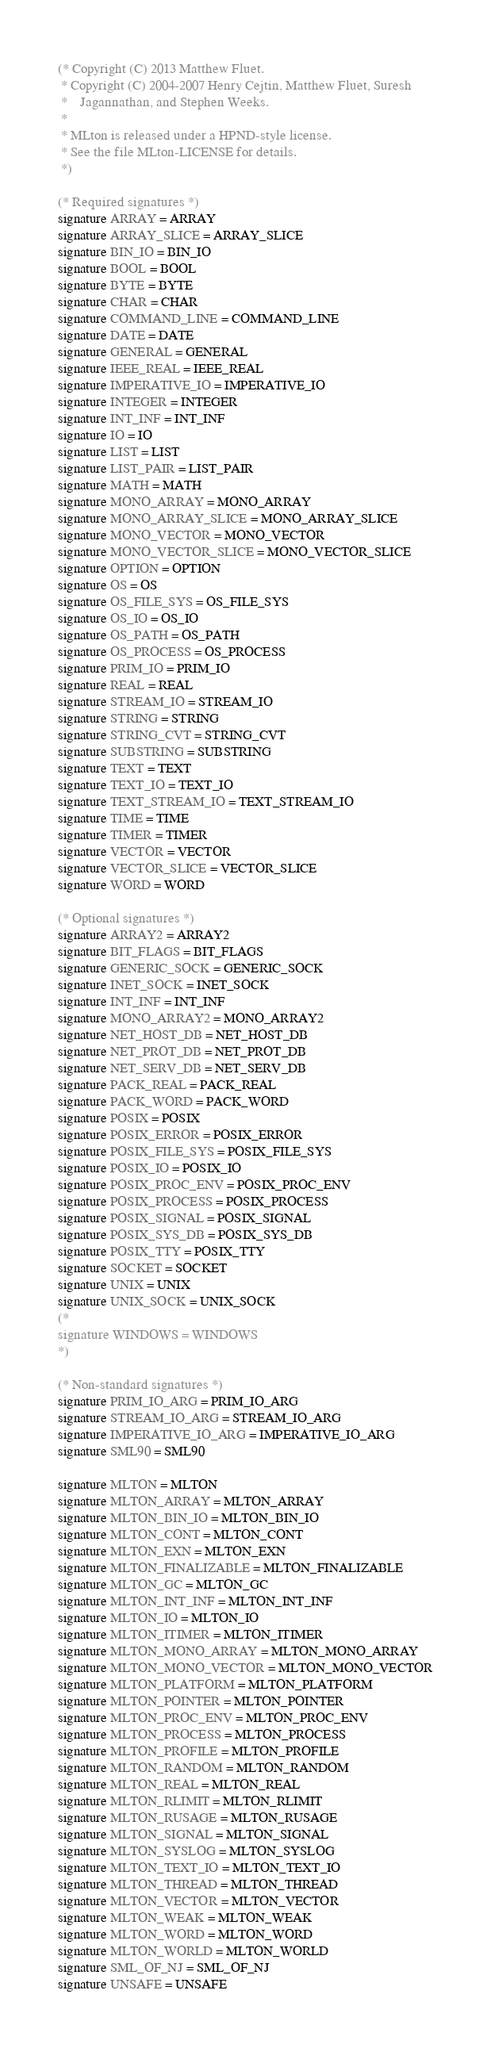<code> <loc_0><loc_0><loc_500><loc_500><_SML_>(* Copyright (C) 2013 Matthew Fluet.
 * Copyright (C) 2004-2007 Henry Cejtin, Matthew Fluet, Suresh
 *    Jagannathan, and Stephen Weeks.
 *
 * MLton is released under a HPND-style license.
 * See the file MLton-LICENSE for details.
 *)

(* Required signatures *)
signature ARRAY = ARRAY 
signature ARRAY_SLICE = ARRAY_SLICE 
signature BIN_IO = BIN_IO 
signature BOOL = BOOL 
signature BYTE = BYTE 
signature CHAR = CHAR 
signature COMMAND_LINE = COMMAND_LINE 
signature DATE = DATE 
signature GENERAL = GENERAL 
signature IEEE_REAL = IEEE_REAL 
signature IMPERATIVE_IO = IMPERATIVE_IO 
signature INTEGER = INTEGER 
signature INT_INF = INT_INF 
signature IO = IO 
signature LIST = LIST 
signature LIST_PAIR = LIST_PAIR 
signature MATH = MATH 
signature MONO_ARRAY = MONO_ARRAY 
signature MONO_ARRAY_SLICE = MONO_ARRAY_SLICE 
signature MONO_VECTOR = MONO_VECTOR 
signature MONO_VECTOR_SLICE = MONO_VECTOR_SLICE 
signature OPTION = OPTION 
signature OS = OS 
signature OS_FILE_SYS = OS_FILE_SYS 
signature OS_IO = OS_IO 
signature OS_PATH = OS_PATH 
signature OS_PROCESS = OS_PROCESS 
signature PRIM_IO = PRIM_IO 
signature REAL = REAL 
signature STREAM_IO = STREAM_IO
signature STRING = STRING 
signature STRING_CVT = STRING_CVT 
signature SUBSTRING = SUBSTRING 
signature TEXT = TEXT 
signature TEXT_IO = TEXT_IO 
signature TEXT_STREAM_IO = TEXT_STREAM_IO 
signature TIME = TIME 
signature TIMER = TIMER 
signature VECTOR = VECTOR 
signature VECTOR_SLICE = VECTOR_SLICE 
signature WORD = WORD

(* Optional signatures *)
signature ARRAY2 = ARRAY2 
signature BIT_FLAGS = BIT_FLAGS 
signature GENERIC_SOCK = GENERIC_SOCK 
signature INET_SOCK = INET_SOCK 
signature INT_INF = INT_INF 
signature MONO_ARRAY2 = MONO_ARRAY2 
signature NET_HOST_DB = NET_HOST_DB 
signature NET_PROT_DB = NET_PROT_DB 
signature NET_SERV_DB = NET_SERV_DB 
signature PACK_REAL = PACK_REAL 
signature PACK_WORD = PACK_WORD 
signature POSIX = POSIX 
signature POSIX_ERROR = POSIX_ERROR 
signature POSIX_FILE_SYS = POSIX_FILE_SYS 
signature POSIX_IO = POSIX_IO 
signature POSIX_PROC_ENV = POSIX_PROC_ENV 
signature POSIX_PROCESS = POSIX_PROCESS 
signature POSIX_SIGNAL = POSIX_SIGNAL 
signature POSIX_SYS_DB = POSIX_SYS_DB 
signature POSIX_TTY = POSIX_TTY 
signature SOCKET = SOCKET 
signature UNIX = UNIX 
signature UNIX_SOCK = UNIX_SOCK 
(*
signature WINDOWS = WINDOWS
*)

(* Non-standard signatures *)
signature PRIM_IO_ARG = PRIM_IO_ARG
signature STREAM_IO_ARG = STREAM_IO_ARG
signature IMPERATIVE_IO_ARG = IMPERATIVE_IO_ARG
signature SML90 = SML90

signature MLTON = MLTON
signature MLTON_ARRAY = MLTON_ARRAY
signature MLTON_BIN_IO = MLTON_BIN_IO
signature MLTON_CONT = MLTON_CONT
signature MLTON_EXN = MLTON_EXN
signature MLTON_FINALIZABLE = MLTON_FINALIZABLE
signature MLTON_GC = MLTON_GC
signature MLTON_INT_INF = MLTON_INT_INF
signature MLTON_IO = MLTON_IO
signature MLTON_ITIMER = MLTON_ITIMER
signature MLTON_MONO_ARRAY = MLTON_MONO_ARRAY
signature MLTON_MONO_VECTOR = MLTON_MONO_VECTOR
signature MLTON_PLATFORM = MLTON_PLATFORM
signature MLTON_POINTER = MLTON_POINTER
signature MLTON_PROC_ENV = MLTON_PROC_ENV
signature MLTON_PROCESS = MLTON_PROCESS
signature MLTON_PROFILE = MLTON_PROFILE
signature MLTON_RANDOM = MLTON_RANDOM
signature MLTON_REAL = MLTON_REAL
signature MLTON_RLIMIT = MLTON_RLIMIT
signature MLTON_RUSAGE = MLTON_RUSAGE
signature MLTON_SIGNAL = MLTON_SIGNAL
signature MLTON_SYSLOG = MLTON_SYSLOG
signature MLTON_TEXT_IO = MLTON_TEXT_IO
signature MLTON_THREAD = MLTON_THREAD
signature MLTON_VECTOR = MLTON_VECTOR
signature MLTON_WEAK = MLTON_WEAK
signature MLTON_WORD = MLTON_WORD
signature MLTON_WORLD = MLTON_WORLD
signature SML_OF_NJ = SML_OF_NJ
signature UNSAFE = UNSAFE
</code> 